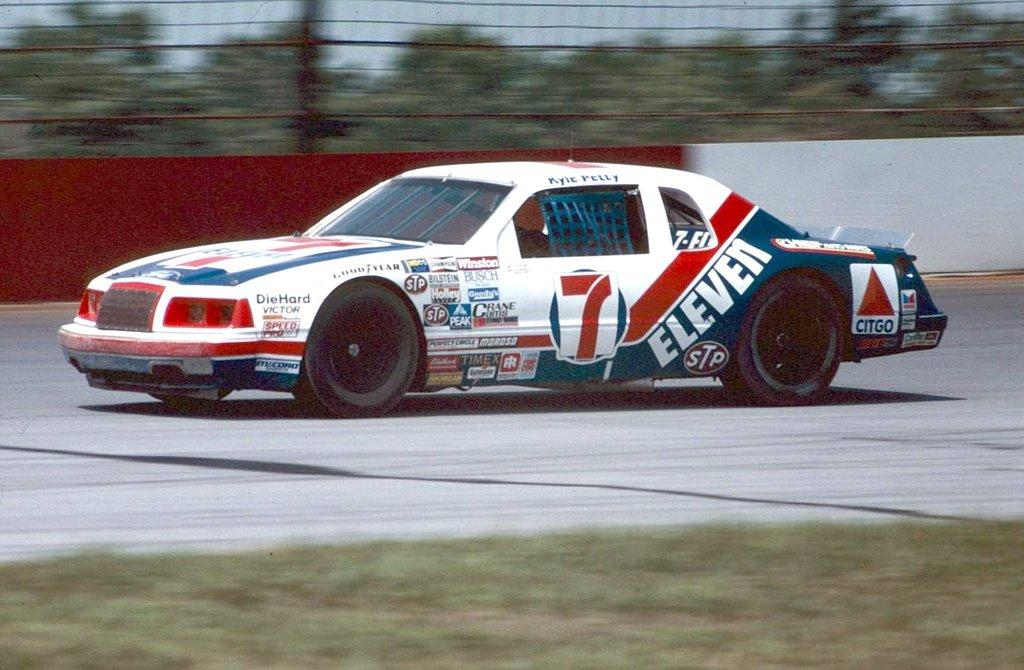What is the main subject of the image? The main subject of the image is a car. What is the car doing in the image? The car is moving on the road in the image. What can be seen in the background of the image? There is a wall and trees in the image. What type of ground surface is visible in the image? There is grass on the ground in the image. What time does the clock on the car show in the image? There is no clock visible on the car in the image. Who is the uncle of the driver in the image? There is no information about the driver or any relatives in the image. 